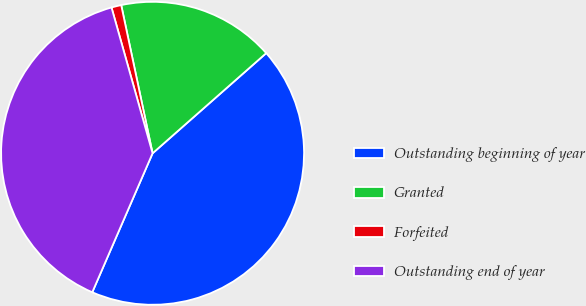<chart> <loc_0><loc_0><loc_500><loc_500><pie_chart><fcel>Outstanding beginning of year<fcel>Granted<fcel>Forfeited<fcel>Outstanding end of year<nl><fcel>43.01%<fcel>16.82%<fcel>1.05%<fcel>39.11%<nl></chart> 